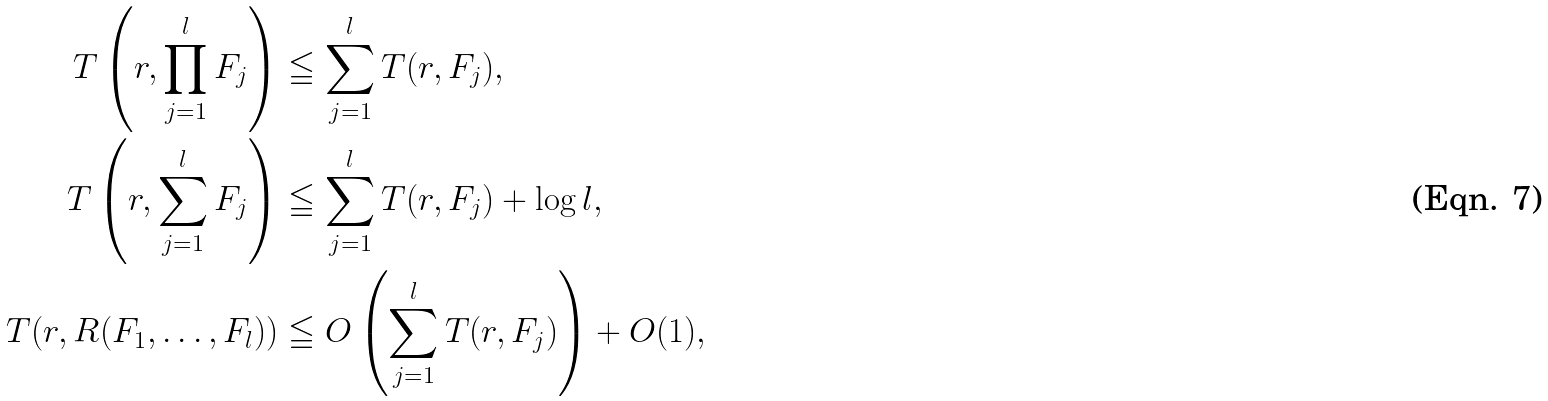Convert formula to latex. <formula><loc_0><loc_0><loc_500><loc_500>T \left ( r , \prod _ { j = 1 } ^ { l } F _ { j } \right ) & \leqq \sum _ { j = 1 } ^ { l } T ( r , F _ { j } ) , \\ T \left ( r , \sum _ { j = 1 } ^ { l } F _ { j } \right ) & \leqq \sum _ { j = 1 } ^ { l } T ( r , F _ { j } ) + \log l , \\ T ( r , R ( F _ { 1 } , \dots , F _ { l } ) ) & \leqq O \left ( \sum _ { j = 1 } ^ { l } T ( r , F _ { j } ) \right ) + O ( 1 ) ,</formula> 